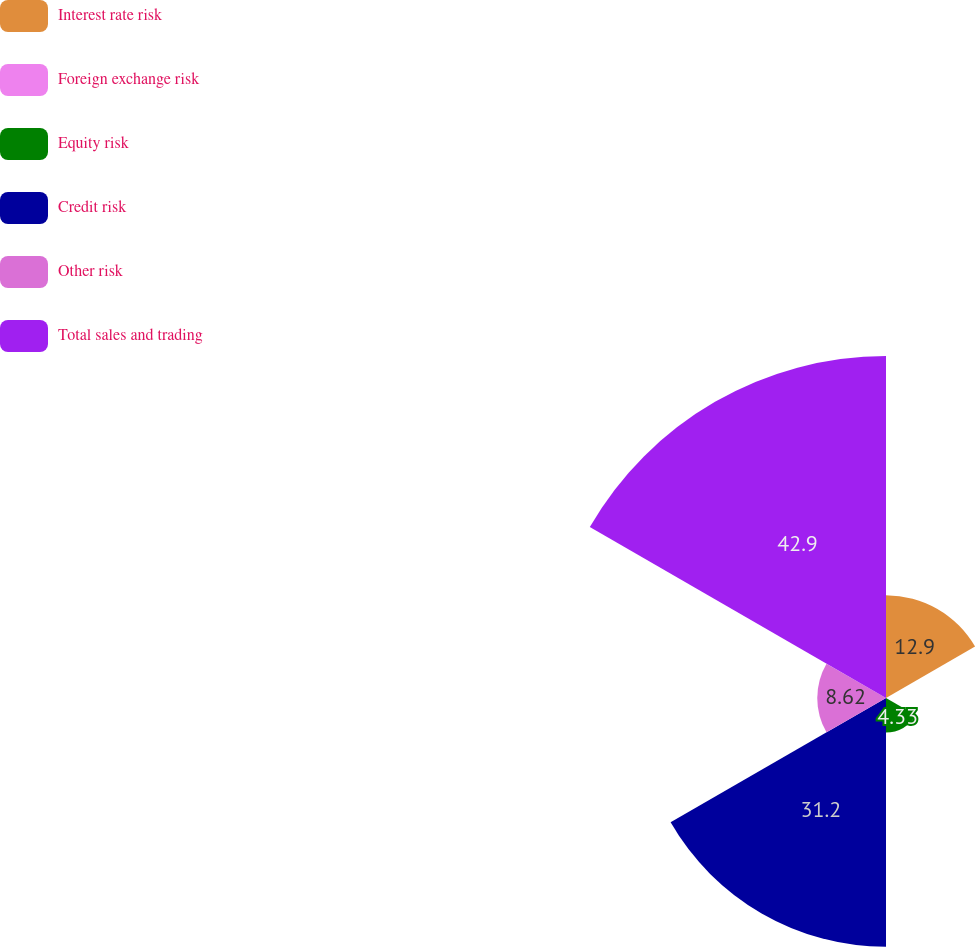Convert chart to OTSL. <chart><loc_0><loc_0><loc_500><loc_500><pie_chart><fcel>Interest rate risk<fcel>Foreign exchange risk<fcel>Equity risk<fcel>Credit risk<fcel>Other risk<fcel>Total sales and trading<nl><fcel>12.9%<fcel>0.05%<fcel>4.33%<fcel>31.2%<fcel>8.62%<fcel>42.9%<nl></chart> 